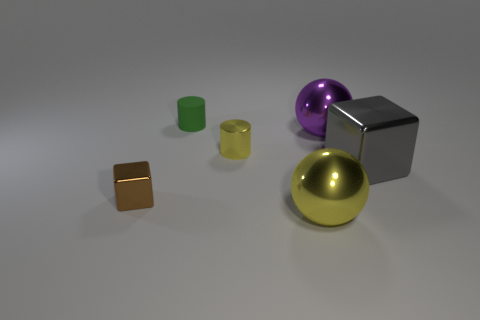Add 2 large cyan objects. How many objects exist? 8 Subtract 0 red balls. How many objects are left? 6 Subtract all large blue metal blocks. Subtract all gray shiny things. How many objects are left? 5 Add 5 shiny cubes. How many shiny cubes are left? 7 Add 3 tiny cyan rubber cylinders. How many tiny cyan rubber cylinders exist? 3 